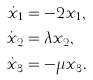<formula> <loc_0><loc_0><loc_500><loc_500>\dot { x } _ { 1 } & = - 2 x _ { 1 } , \\ \dot { x } _ { 2 } & = \lambda x _ { 2 } , \\ \dot { x } _ { 3 } & = - \mu x _ { 3 } .</formula> 